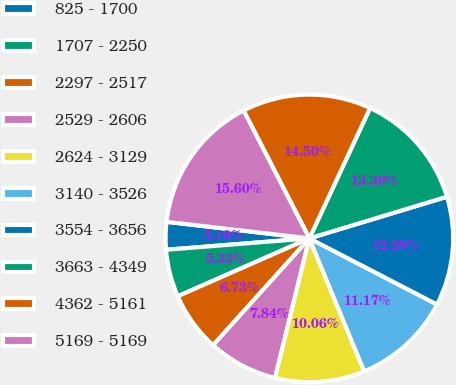Convert chart. <chart><loc_0><loc_0><loc_500><loc_500><pie_chart><fcel>825 - 1700<fcel>1707 - 2250<fcel>2297 - 2517<fcel>2529 - 2606<fcel>2624 - 3129<fcel>3140 - 3526<fcel>3554 - 3656<fcel>3663 - 4349<fcel>4362 - 5161<fcel>5169 - 5169<nl><fcel>3.1%<fcel>5.33%<fcel>6.73%<fcel>7.84%<fcel>10.06%<fcel>11.17%<fcel>12.28%<fcel>13.39%<fcel>14.5%<fcel>15.6%<nl></chart> 